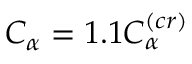Convert formula to latex. <formula><loc_0><loc_0><loc_500><loc_500>C _ { \alpha } = 1 . 1 C _ { \alpha } ^ { ( c r ) }</formula> 